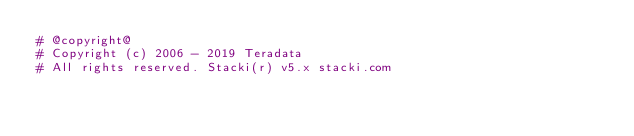<code> <loc_0><loc_0><loc_500><loc_500><_Python_># @copyright@
# Copyright (c) 2006 - 2019 Teradata
# All rights reserved. Stacki(r) v5.x stacki.com</code> 